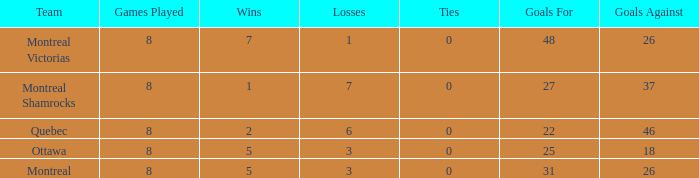For teams with more than 0 ties and goals against of 37, how many wins were tallied? None. 